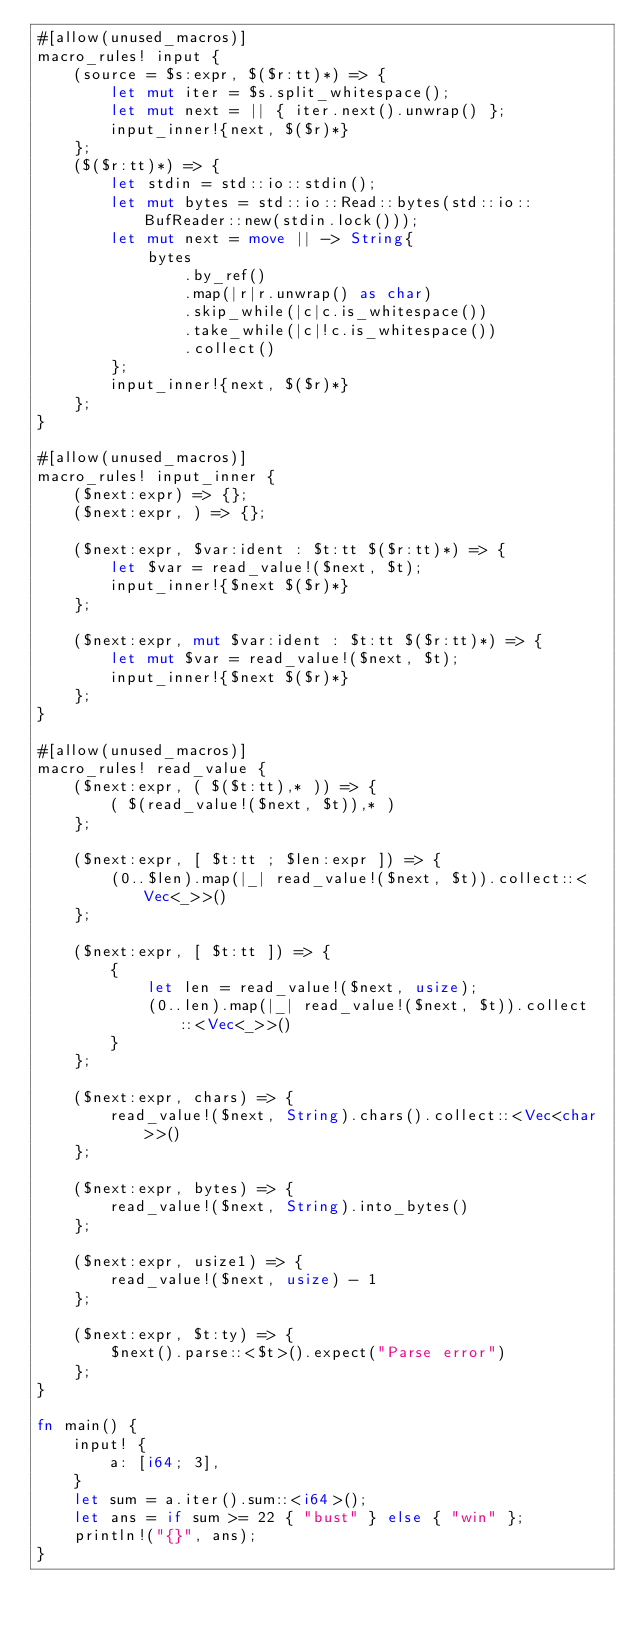Convert code to text. <code><loc_0><loc_0><loc_500><loc_500><_Rust_>#[allow(unused_macros)]
macro_rules! input {
    (source = $s:expr, $($r:tt)*) => {
        let mut iter = $s.split_whitespace();
        let mut next = || { iter.next().unwrap() };
        input_inner!{next, $($r)*}
    };
    ($($r:tt)*) => {
        let stdin = std::io::stdin();
        let mut bytes = std::io::Read::bytes(std::io::BufReader::new(stdin.lock()));
        let mut next = move || -> String{
            bytes
                .by_ref()
                .map(|r|r.unwrap() as char)
                .skip_while(|c|c.is_whitespace())
                .take_while(|c|!c.is_whitespace())
                .collect()
        };
        input_inner!{next, $($r)*}
    };
}

#[allow(unused_macros)]
macro_rules! input_inner {
    ($next:expr) => {};
    ($next:expr, ) => {};

    ($next:expr, $var:ident : $t:tt $($r:tt)*) => {
        let $var = read_value!($next, $t);
        input_inner!{$next $($r)*}
    };

    ($next:expr, mut $var:ident : $t:tt $($r:tt)*) => {
        let mut $var = read_value!($next, $t);
        input_inner!{$next $($r)*}
    };
}

#[allow(unused_macros)]
macro_rules! read_value {
    ($next:expr, ( $($t:tt),* )) => {
        ( $(read_value!($next, $t)),* )
    };

    ($next:expr, [ $t:tt ; $len:expr ]) => {
        (0..$len).map(|_| read_value!($next, $t)).collect::<Vec<_>>()
    };

    ($next:expr, [ $t:tt ]) => {
        {
            let len = read_value!($next, usize);
            (0..len).map(|_| read_value!($next, $t)).collect::<Vec<_>>()
        }
    };

    ($next:expr, chars) => {
        read_value!($next, String).chars().collect::<Vec<char>>()
    };

    ($next:expr, bytes) => {
        read_value!($next, String).into_bytes()
    };

    ($next:expr, usize1) => {
        read_value!($next, usize) - 1
    };

    ($next:expr, $t:ty) => {
        $next().parse::<$t>().expect("Parse error")
    };
}

fn main() {
    input! {
        a: [i64; 3],
    }
    let sum = a.iter().sum::<i64>();
    let ans = if sum >= 22 { "bust" } else { "win" };
    println!("{}", ans);
}
</code> 